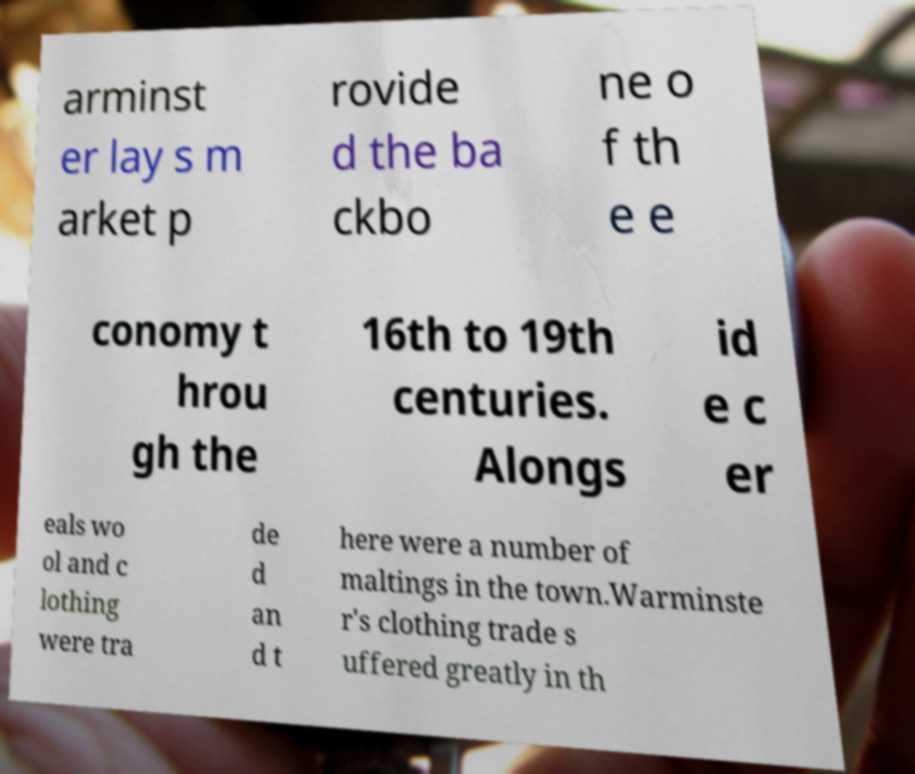Please identify and transcribe the text found in this image. arminst er lay s m arket p rovide d the ba ckbo ne o f th e e conomy t hrou gh the 16th to 19th centuries. Alongs id e c er eals wo ol and c lothing were tra de d an d t here were a number of maltings in the town.Warminste r's clothing trade s uffered greatly in th 